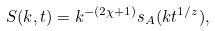<formula> <loc_0><loc_0><loc_500><loc_500>S ( k , t ) = k ^ { - ( 2 \chi + 1 ) } s _ { A } ( k t ^ { 1 / z } ) ,</formula> 